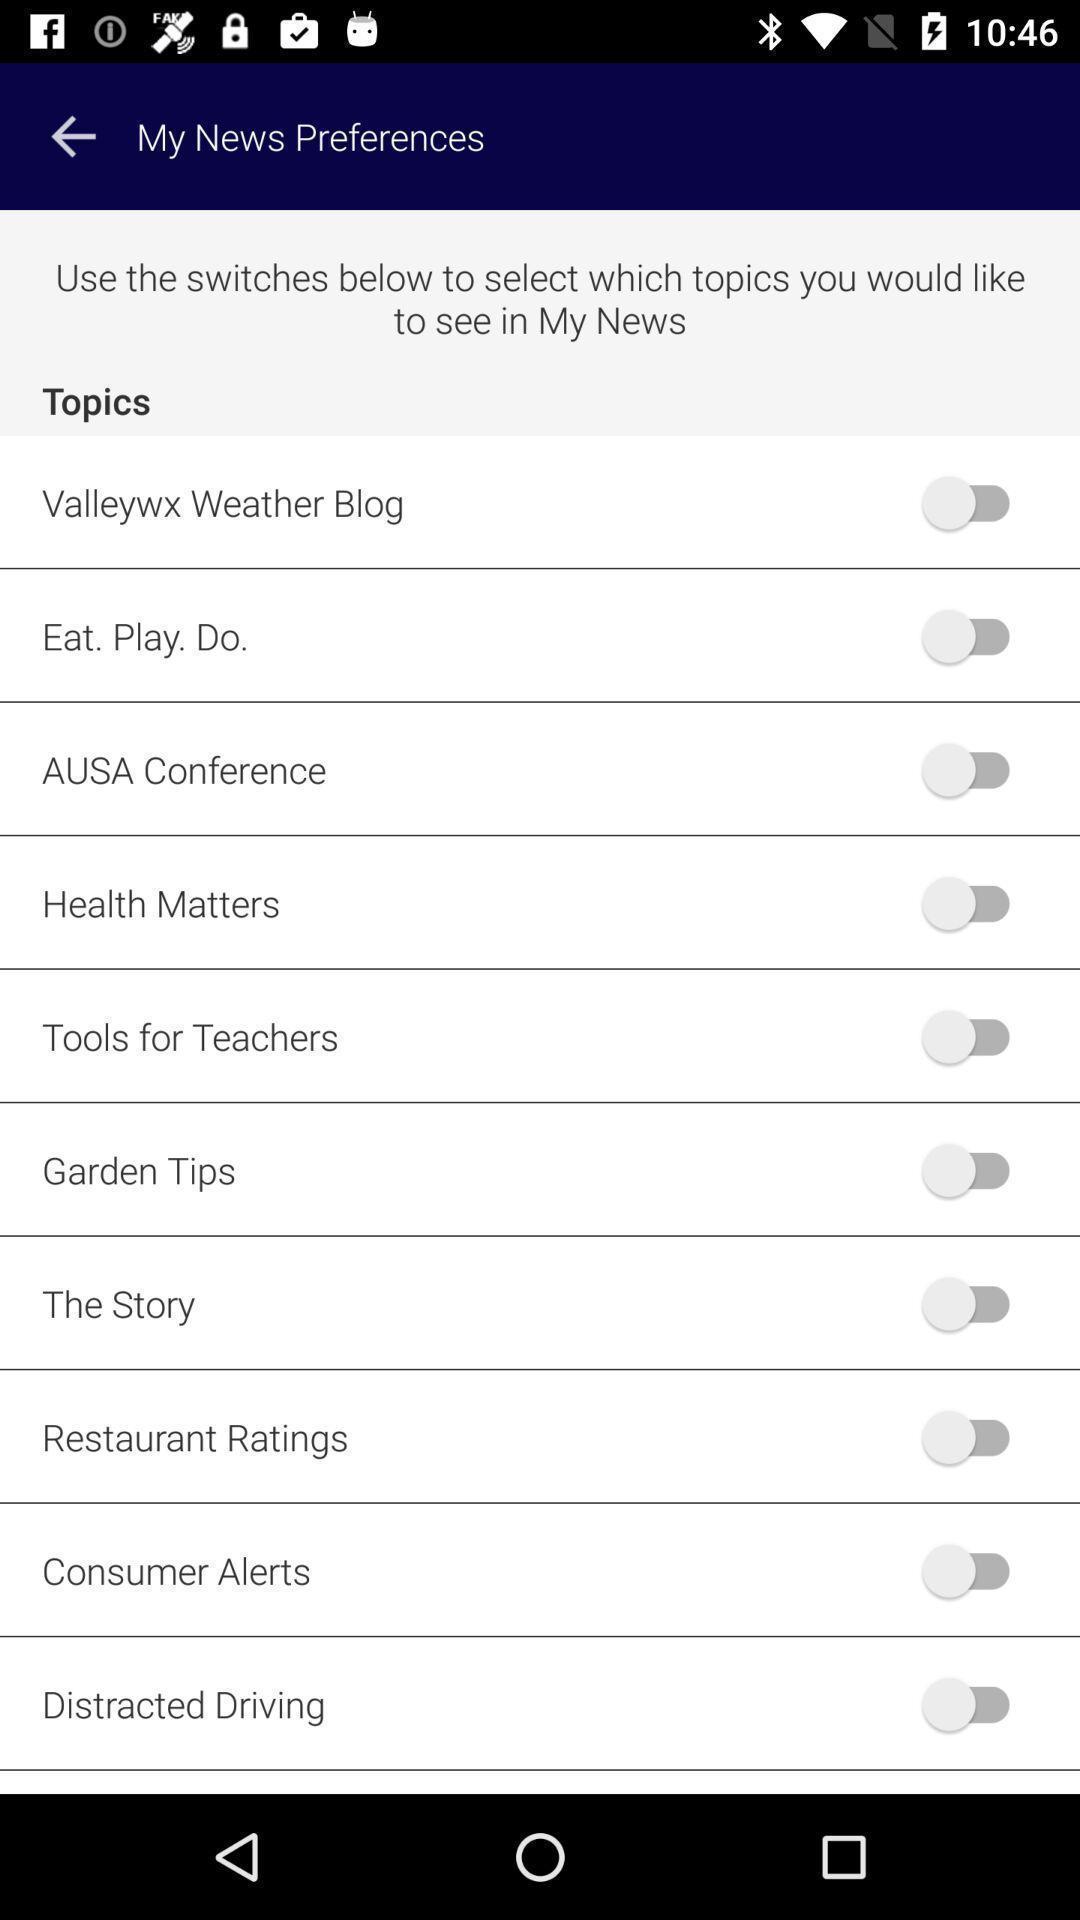Tell me what you see in this picture. Various preferences displayed of news app. 